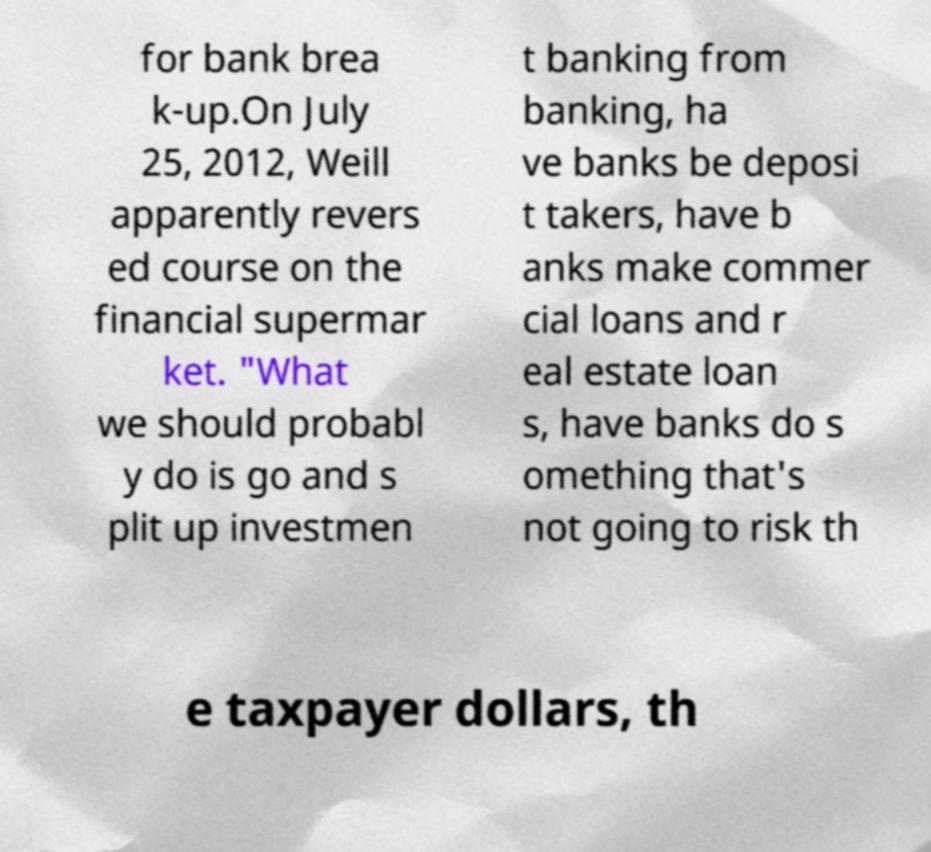For documentation purposes, I need the text within this image transcribed. Could you provide that? for bank brea k-up.On July 25, 2012, Weill apparently revers ed course on the financial supermar ket. "What we should probabl y do is go and s plit up investmen t banking from banking, ha ve banks be deposi t takers, have b anks make commer cial loans and r eal estate loan s, have banks do s omething that's not going to risk th e taxpayer dollars, th 